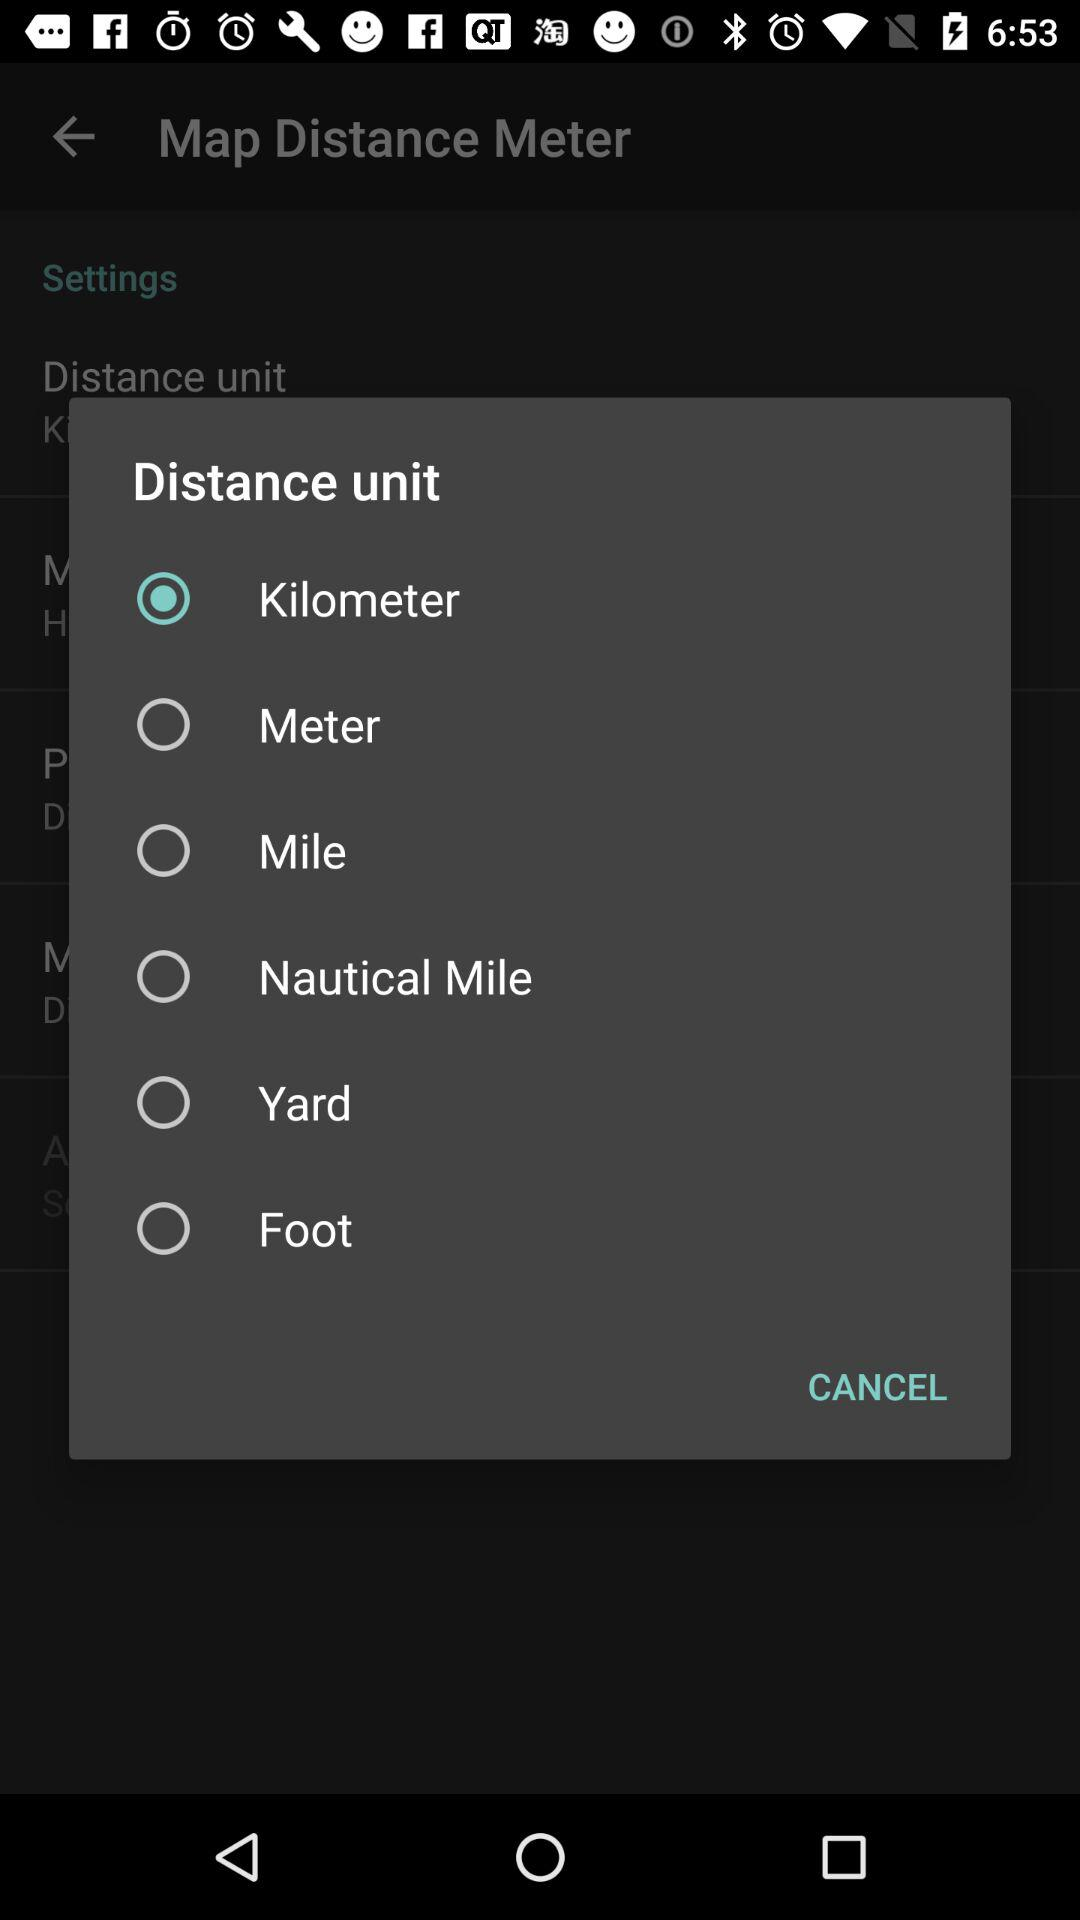How many distance units are there?
Answer the question using a single word or phrase. 6 